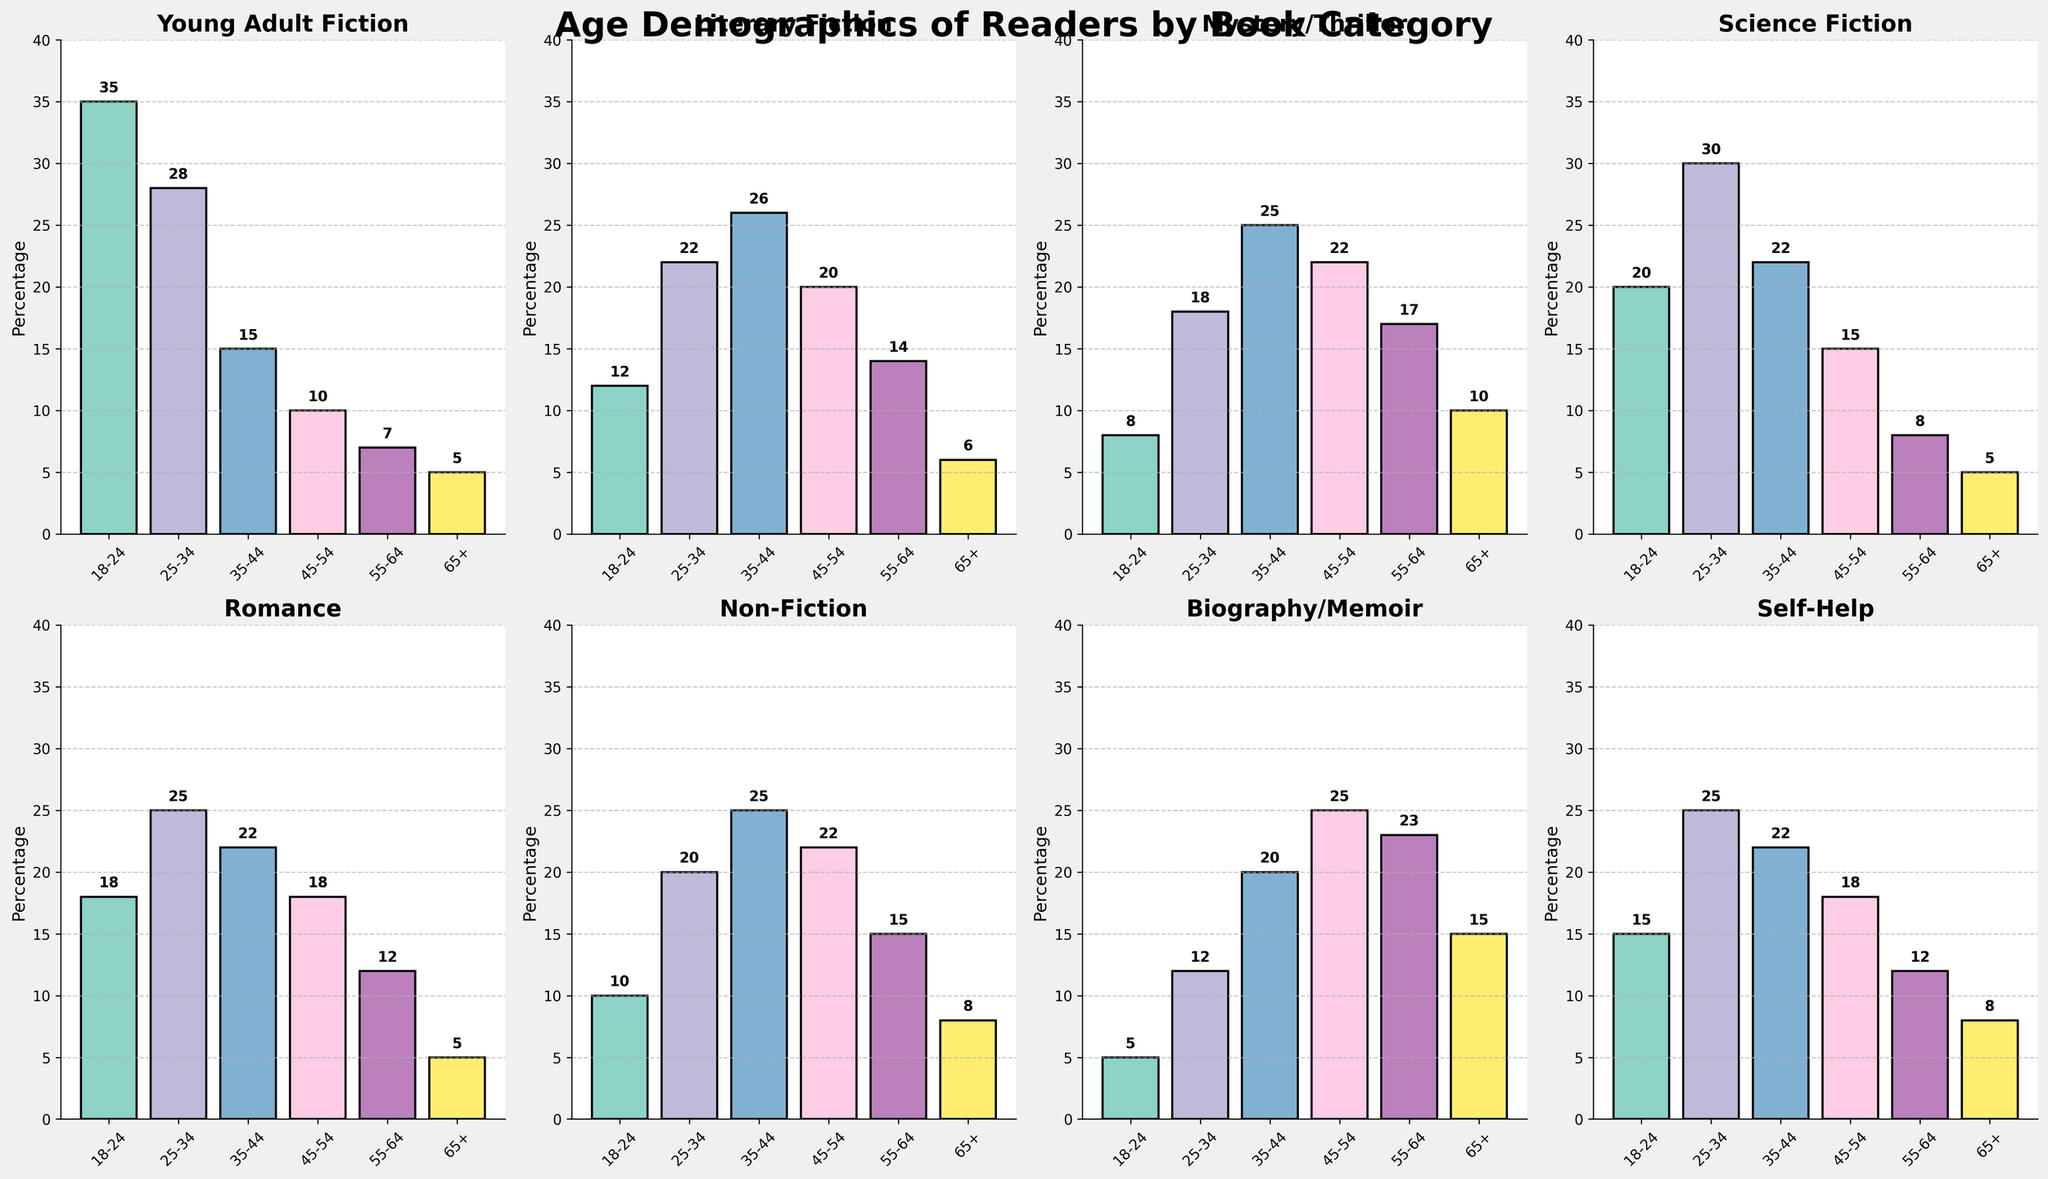What is the age group with the highest percentage of readers for Young Adult Fiction? The highest bar in the subplot for Young Adult Fiction represents the 18-24 age group. Its height is 35, indicating it has the highest percentage.
Answer: 18-24 What is the average percentage of readers in all age groups for Literary Fiction? Sum the percentages: 12 + 22 + 26 + 20 + 14 + 6 = 100, then divide by the number of age groups (6), so the average is 100/6 = 16.67.
Answer: 16.67 Which book category has the highest percentage of readers aged 35-44? Compare the heights of the bars labeled 35-44 across all subplots. The tallest bar in this age group is in the Mystery/Thriller subplot with a value of 25.
Answer: Mystery/Thriller Are there more readers aged 55-64 for Biography/Memoir or Science Fiction? Compare the height of the bars for the 55-64 age group in the Biography/Memoir and Science Fiction subplots. Biography/Memoir has a higher value at 23 compared to Science Fiction's 8.
Answer: Biography/Memoir How does the percentage of readers aged 65+ for Non-Fiction compare to that for Self-Help? The height of the bar for the 65+ age group in Non-Fiction is 8, and for Self-Help, it is also 8. Thus, the percentages are equal.
Answer: Equal Which book category has the most evenly distributed reader demographics across all age groups? By analyzing the bar heights for all categories, Literary Fiction seems to have the most balanced heights across the six age groups, indicating a more even distribution.
Answer: Literary Fiction What is the total percentage of readers aged 18-34 for Romance? Add the percentages for the 18-24 and 25-34 age groups in the Romance subplot: 18 + 25 = 43.
Answer: 43 Is the percentage of readers aged 45-54 higher in Self-Help or Literary Fiction? Compare the corresponding bars in the subplots. Self-Help has a value of 18, and Literary Fiction has a value of 20. Literary Fiction is higher.
Answer: Literary Fiction What is the percentage difference between the youngest (18-24) and oldest (65+) age groups for Mystery/Thriller? Subtract the value of the 65+ age group (10) from the 18-24 age group (8): 8 - 10 = -2.
Answer: -2 